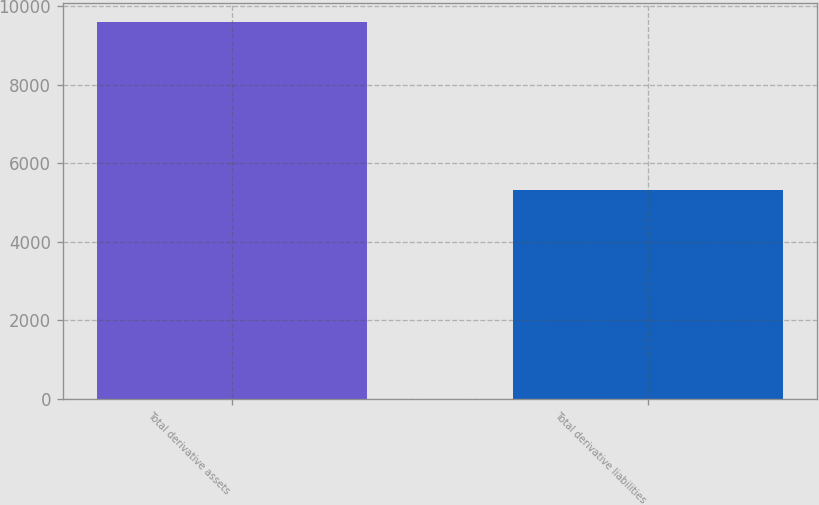Convert chart to OTSL. <chart><loc_0><loc_0><loc_500><loc_500><bar_chart><fcel>Total derivative assets<fcel>Total derivative liabilities<nl><fcel>9600<fcel>5312<nl></chart> 